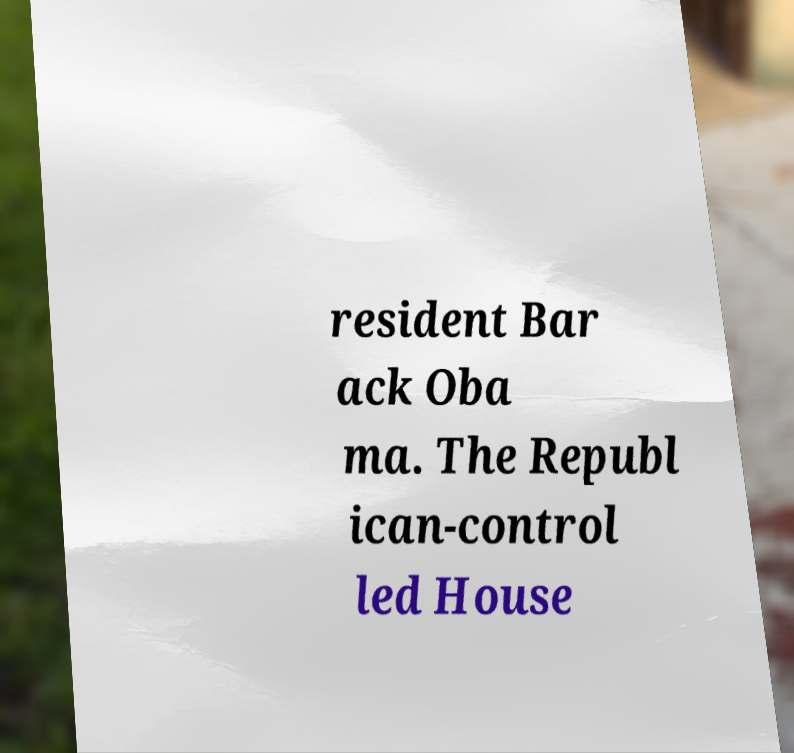I need the written content from this picture converted into text. Can you do that? resident Bar ack Oba ma. The Republ ican-control led House 